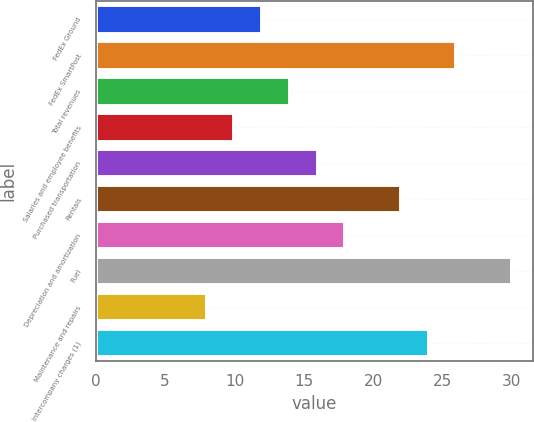Convert chart. <chart><loc_0><loc_0><loc_500><loc_500><bar_chart><fcel>FedEx Ground<fcel>FedEx SmartPost<fcel>Total revenues<fcel>Salaries and employee benefits<fcel>Purchased transportation<fcel>Rentals<fcel>Depreciation and amortization<fcel>Fuel<fcel>Maintenance and repairs<fcel>Intercompany charges (1)<nl><fcel>12<fcel>26<fcel>14<fcel>10<fcel>16<fcel>22<fcel>18<fcel>30<fcel>8<fcel>24<nl></chart> 